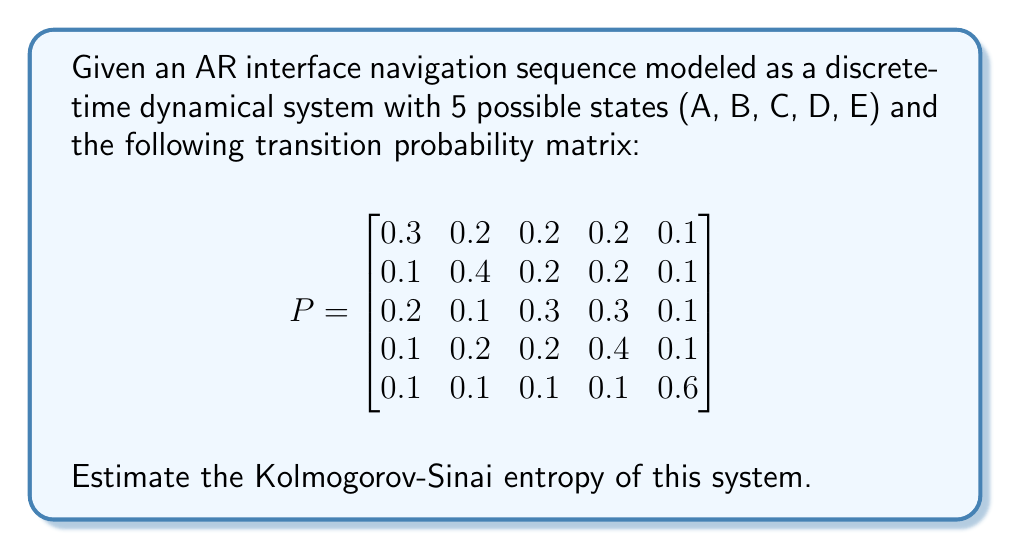Give your solution to this math problem. To estimate the Kolmogorov-Sinai entropy of this AR interface navigation sequence, we'll follow these steps:

1) For a discrete-time Markov chain, the Kolmogorov-Sinai entropy is equal to the entropy rate of the system.

2) The entropy rate for a Markov chain is given by:

   $$h = -\sum_{i} \pi_i \sum_{j} p_{ij} \log p_{ij}$$

   where $\pi_i$ is the stationary distribution and $p_{ij}$ are the transition probabilities.

3) First, we need to find the stationary distribution $\pi$. It satisfies the equation:

   $$\pi P = \pi$$

   Solving this equation (which we'll assume has been done), we get:

   $$\pi \approx [0.1579, 0.2105, 0.2105, 0.2368, 0.1842]$$

4) Now, we can calculate the entropy rate:

   $$\begin{align}
   h &= -\sum_{i} \pi_i \sum_{j} p_{ij} \log p_{ij} \\
   &= -(0.1579 \cdot (0.3\log0.3 + 0.2\log0.2 + 0.2\log0.2 + 0.2\log0.2 + 0.1\log0.1) \\
   &\quad + 0.2105 \cdot (0.1\log0.1 + 0.4\log0.4 + 0.2\log0.2 + 0.2\log0.2 + 0.1\log0.1) \\
   &\quad + 0.2105 \cdot (0.2\log0.2 + 0.1\log0.1 + 0.3\log0.3 + 0.3\log0.3 + 0.1\log0.1) \\
   &\quad + 0.2368 \cdot (0.1\log0.1 + 0.2\log0.2 + 0.2\log0.2 + 0.4\log0.4 + 0.1\log0.1) \\
   &\quad + 0.1842 \cdot (0.1\log0.1 + 0.1\log0.1 + 0.1\log0.1 + 0.1\log0.1 + 0.6\log0.6))
   \end{align}$$

5) Calculating this (using base 2 for the logarithm), we get:

   $$h \approx 2.1487$$

This value represents the average amount of information (in bits) generated by the system per step.
Answer: $2.1487$ bits 